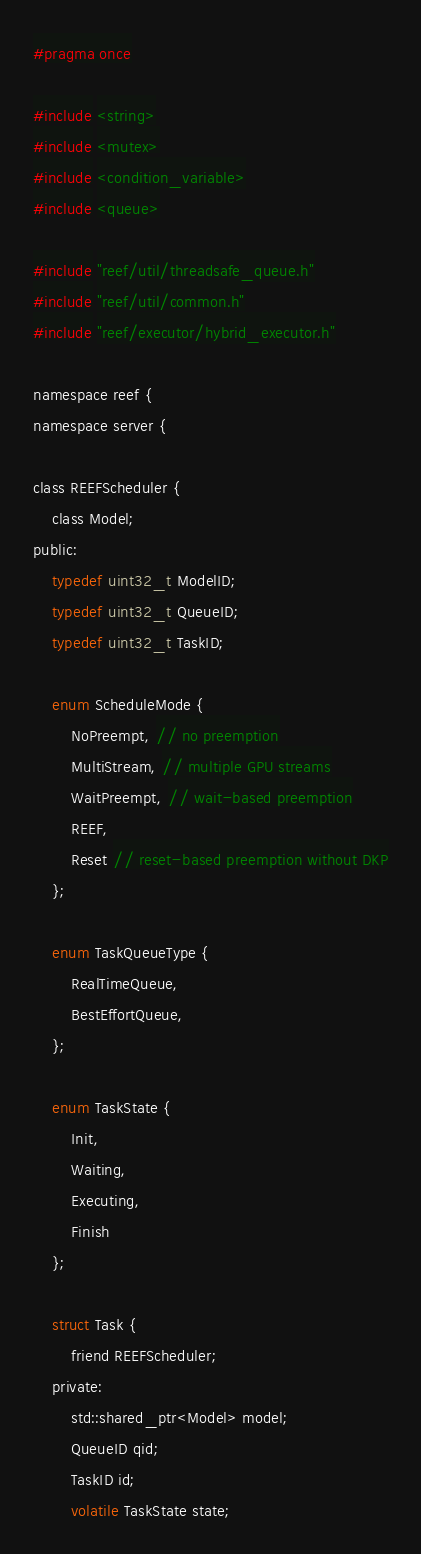<code> <loc_0><loc_0><loc_500><loc_500><_C_>#pragma once

#include <string>
#include <mutex>
#include <condition_variable>
#include <queue>

#include "reef/util/threadsafe_queue.h"
#include "reef/util/common.h"
#include "reef/executor/hybrid_executor.h"

namespace reef {
namespace server {

class REEFScheduler {
    class Model;
public:
    typedef uint32_t ModelID;
    typedef uint32_t QueueID;
    typedef uint32_t TaskID;
    
    enum ScheduleMode {
        NoPreempt, // no preemption
        MultiStream, // multiple GPU streams
        WaitPreempt, // wait-based preemption
        REEF,
        Reset // reset-based preemption without DKP
    };

    enum TaskQueueType {
        RealTimeQueue,
        BestEffortQueue,
    };

    enum TaskState {
        Init,
        Waiting,
        Executing,
        Finish    
    };

    struct Task {
        friend REEFScheduler;
    private:
        std::shared_ptr<Model> model;
        QueueID qid;
        TaskID id;
        volatile TaskState state;</code> 